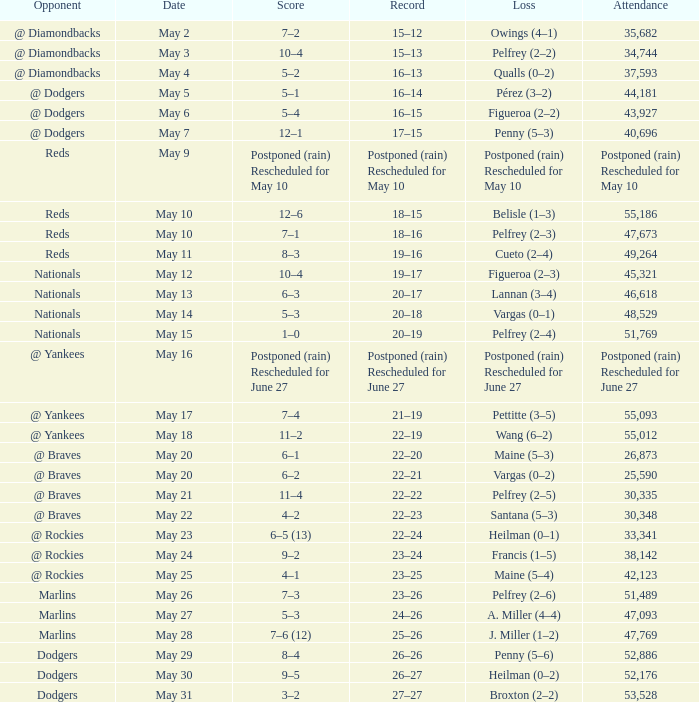Opponent of @ braves, and a Loss of pelfrey (2–5) had what score? 11–4. 